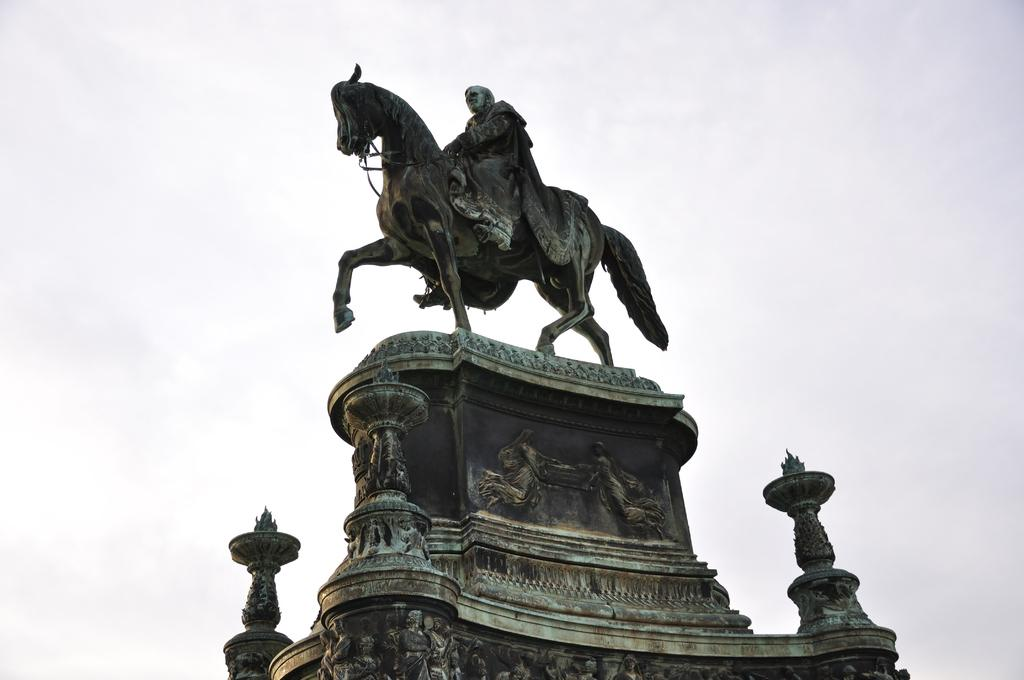What is the main object in the front of the image? There is an object in the front of the image. What is depicted on top of the object? There is a statue of a person and a horse on top of the object. How would you describe the sky in the image? The sky is cloudy in the image. What type of artwork is present on the object? There is a sculpture on the object. What type of canvas is visible in the image? There is no canvas present in the image. Can you describe the texture of the leather in the image? There is no leather present in the image. 